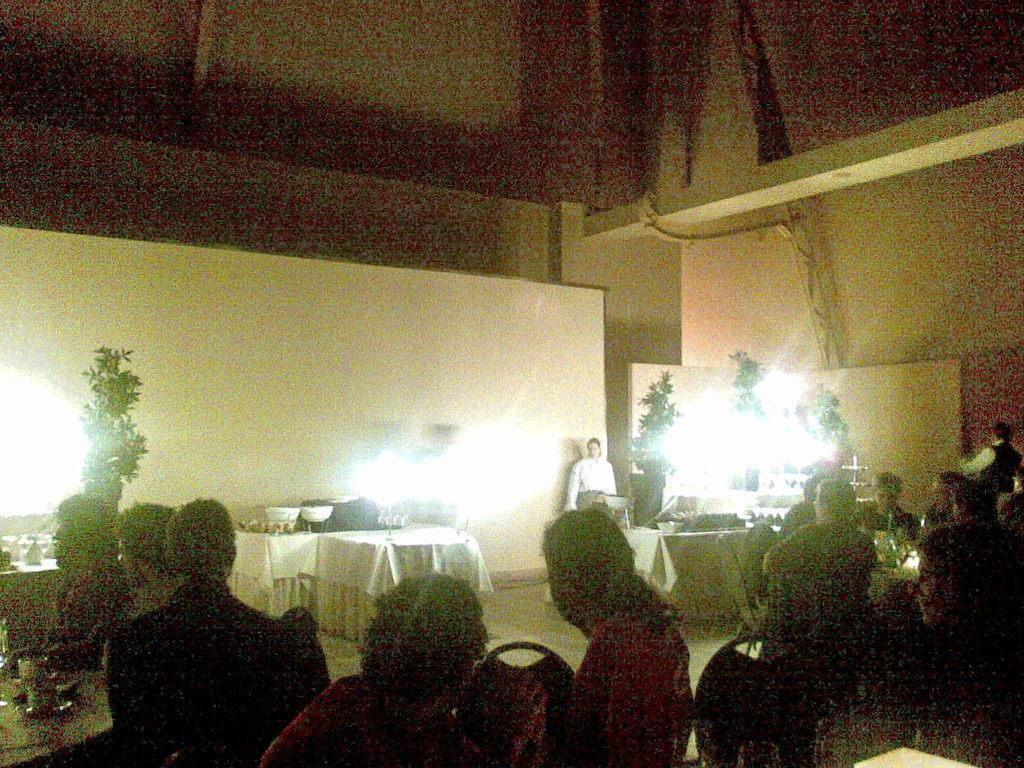In one or two sentences, can you explain what this image depicts? There are persons sitting on chairs arranged on the floor, on which there are tables arranged. In the background, there are plants, lights, a person and there is a wall. 